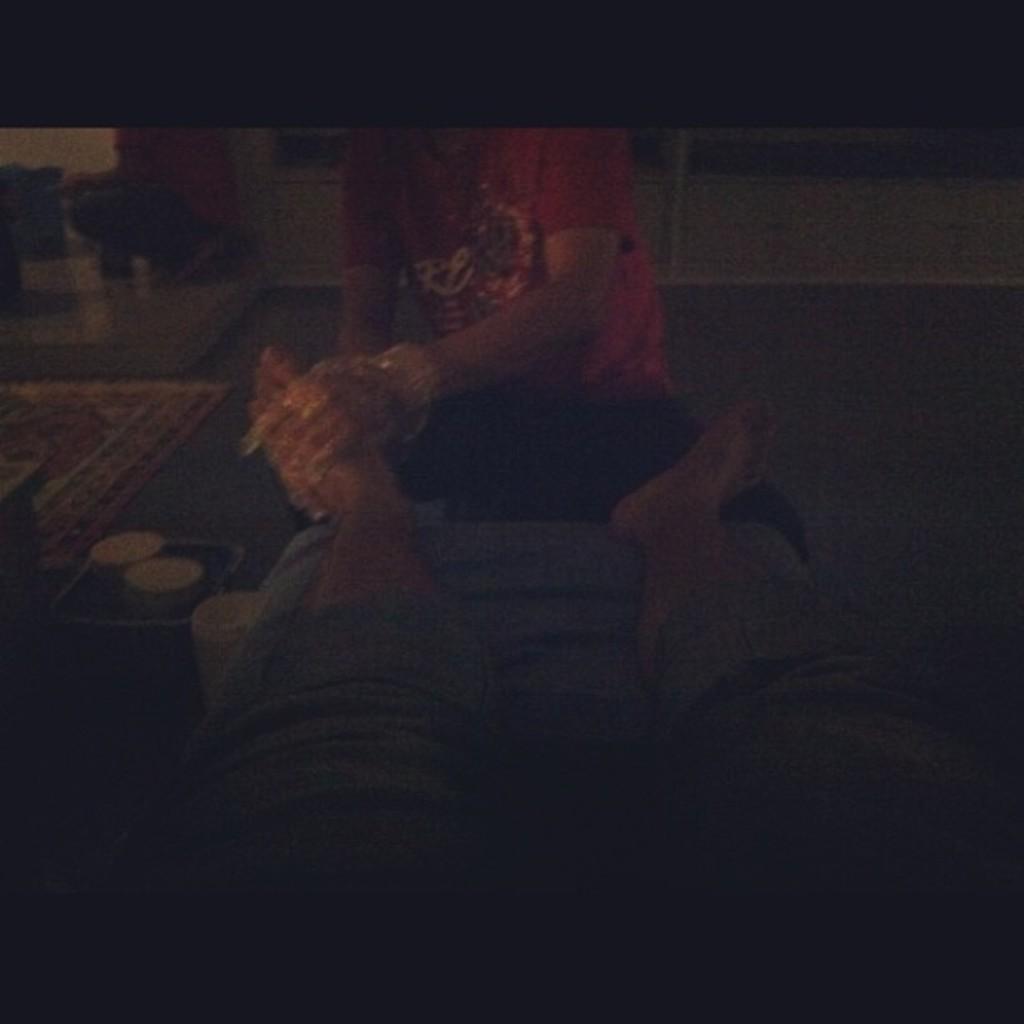In one or two sentences, can you explain what this image depicts? At the bottom of the image there are legs of a person. Behind the legs there is a person sitting and holding a leg. On the left side of the image on the floor there are few things. And there is a blur background. 